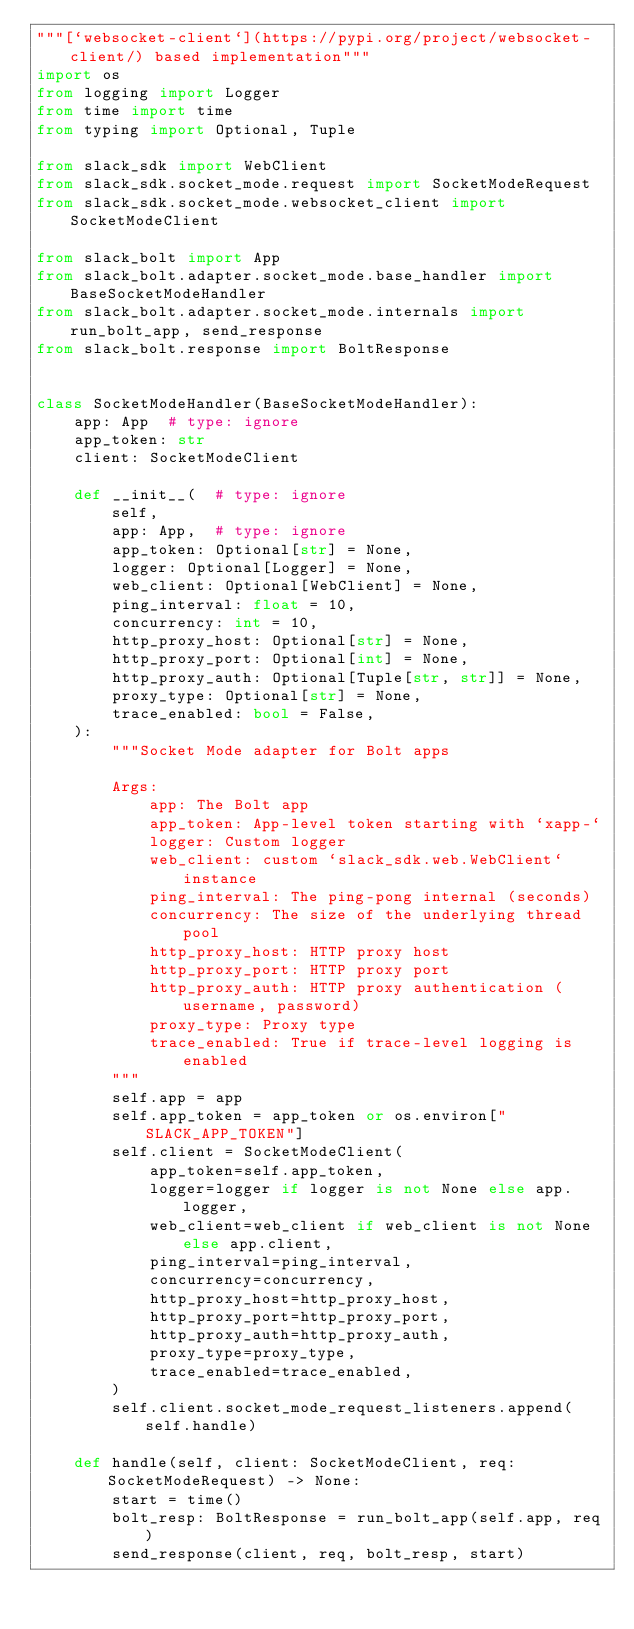<code> <loc_0><loc_0><loc_500><loc_500><_Python_>"""[`websocket-client`](https://pypi.org/project/websocket-client/) based implementation"""
import os
from logging import Logger
from time import time
from typing import Optional, Tuple

from slack_sdk import WebClient
from slack_sdk.socket_mode.request import SocketModeRequest
from slack_sdk.socket_mode.websocket_client import SocketModeClient

from slack_bolt import App
from slack_bolt.adapter.socket_mode.base_handler import BaseSocketModeHandler
from slack_bolt.adapter.socket_mode.internals import run_bolt_app, send_response
from slack_bolt.response import BoltResponse


class SocketModeHandler(BaseSocketModeHandler):
    app: App  # type: ignore
    app_token: str
    client: SocketModeClient

    def __init__(  # type: ignore
        self,
        app: App,  # type: ignore
        app_token: Optional[str] = None,
        logger: Optional[Logger] = None,
        web_client: Optional[WebClient] = None,
        ping_interval: float = 10,
        concurrency: int = 10,
        http_proxy_host: Optional[str] = None,
        http_proxy_port: Optional[int] = None,
        http_proxy_auth: Optional[Tuple[str, str]] = None,
        proxy_type: Optional[str] = None,
        trace_enabled: bool = False,
    ):
        """Socket Mode adapter for Bolt apps

        Args:
            app: The Bolt app
            app_token: App-level token starting with `xapp-`
            logger: Custom logger
            web_client: custom `slack_sdk.web.WebClient` instance
            ping_interval: The ping-pong internal (seconds)
            concurrency: The size of the underlying thread pool
            http_proxy_host: HTTP proxy host
            http_proxy_port: HTTP proxy port
            http_proxy_auth: HTTP proxy authentication (username, password)
            proxy_type: Proxy type
            trace_enabled: True if trace-level logging is enabled
        """
        self.app = app
        self.app_token = app_token or os.environ["SLACK_APP_TOKEN"]
        self.client = SocketModeClient(
            app_token=self.app_token,
            logger=logger if logger is not None else app.logger,
            web_client=web_client if web_client is not None else app.client,
            ping_interval=ping_interval,
            concurrency=concurrency,
            http_proxy_host=http_proxy_host,
            http_proxy_port=http_proxy_port,
            http_proxy_auth=http_proxy_auth,
            proxy_type=proxy_type,
            trace_enabled=trace_enabled,
        )
        self.client.socket_mode_request_listeners.append(self.handle)

    def handle(self, client: SocketModeClient, req: SocketModeRequest) -> None:
        start = time()
        bolt_resp: BoltResponse = run_bolt_app(self.app, req)
        send_response(client, req, bolt_resp, start)
</code> 